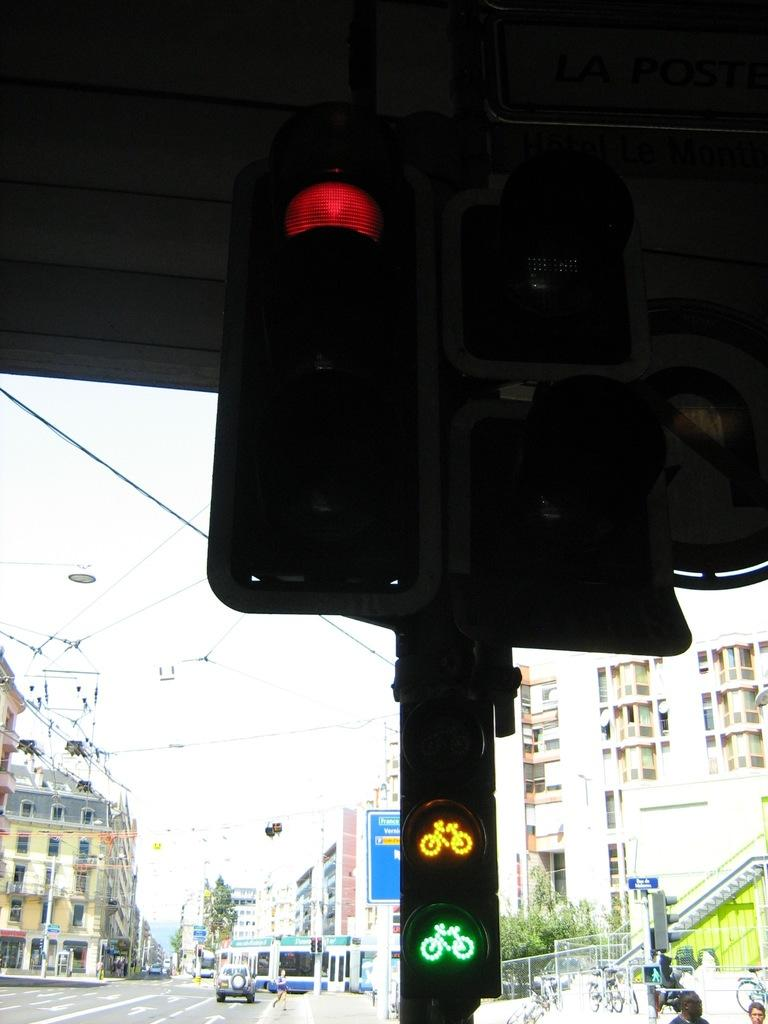What is located on the pole in the image? There is a pole with traffic signals in the image. What can be seen in the background of the image? There is a road, vehicles, buildings, wires, and the sky visible in the background of the image. What type of reward is hanging from the pole in the image? There is no reward hanging from the pole in the image; it has traffic signals. 